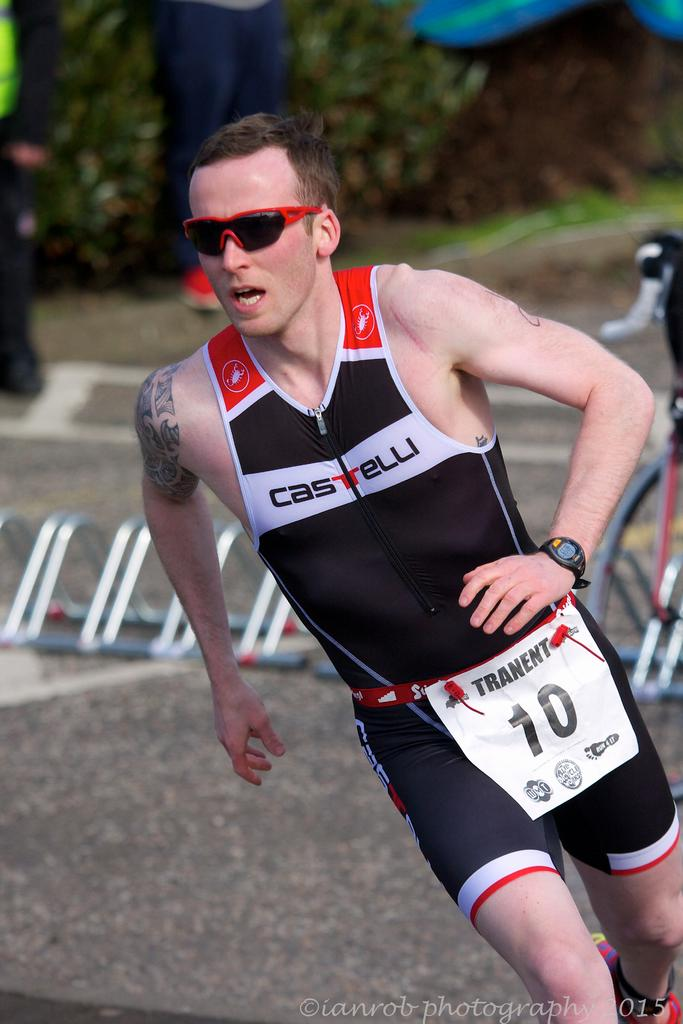<image>
Render a clear and concise summary of the photo. a person with the number ten on an item they have 